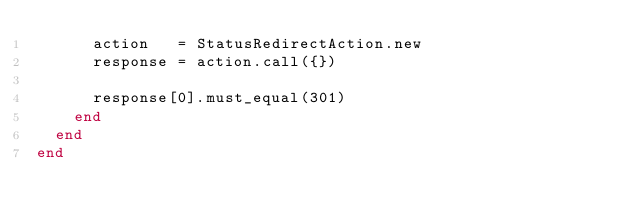<code> <loc_0><loc_0><loc_500><loc_500><_Ruby_>      action   = StatusRedirectAction.new
      response = action.call({})

      response[0].must_equal(301)
    end
  end
end
</code> 